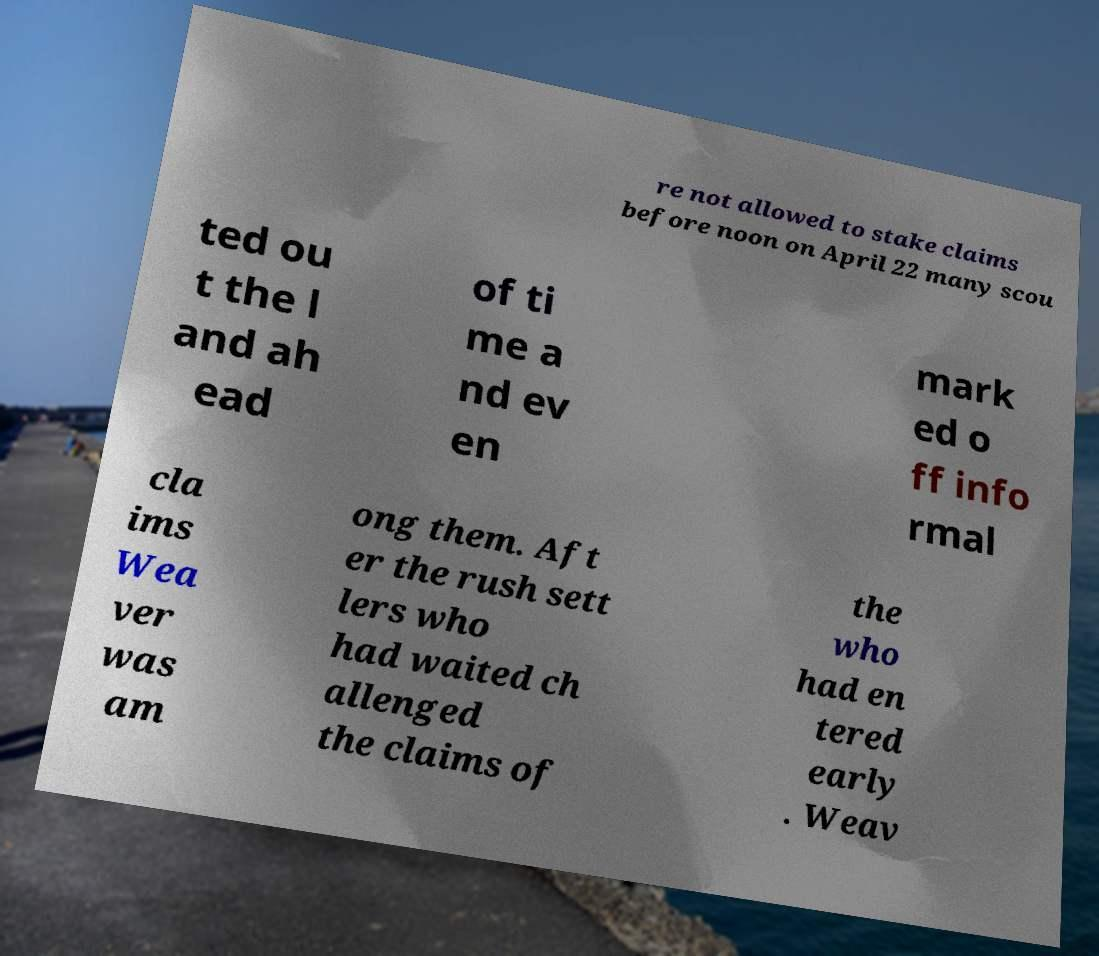For documentation purposes, I need the text within this image transcribed. Could you provide that? re not allowed to stake claims before noon on April 22 many scou ted ou t the l and ah ead of ti me a nd ev en mark ed o ff info rmal cla ims Wea ver was am ong them. Aft er the rush sett lers who had waited ch allenged the claims of the who had en tered early . Weav 